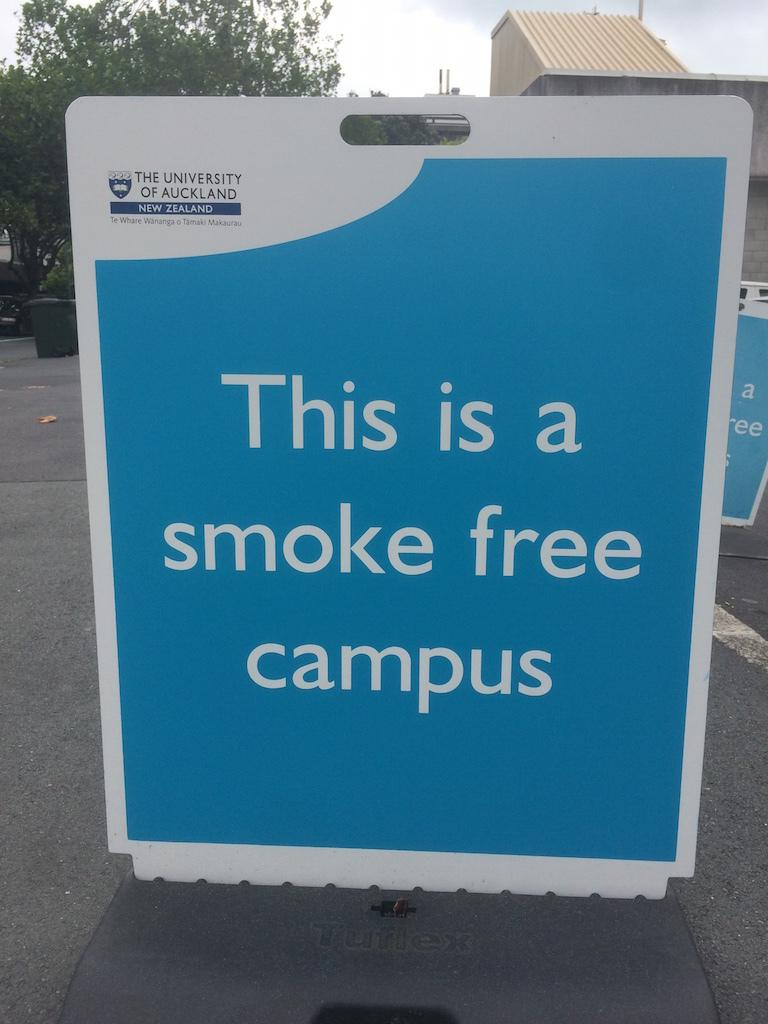<image>
Render a clear and concise summary of the photo. A sign that says"this is a smoke free campus." 